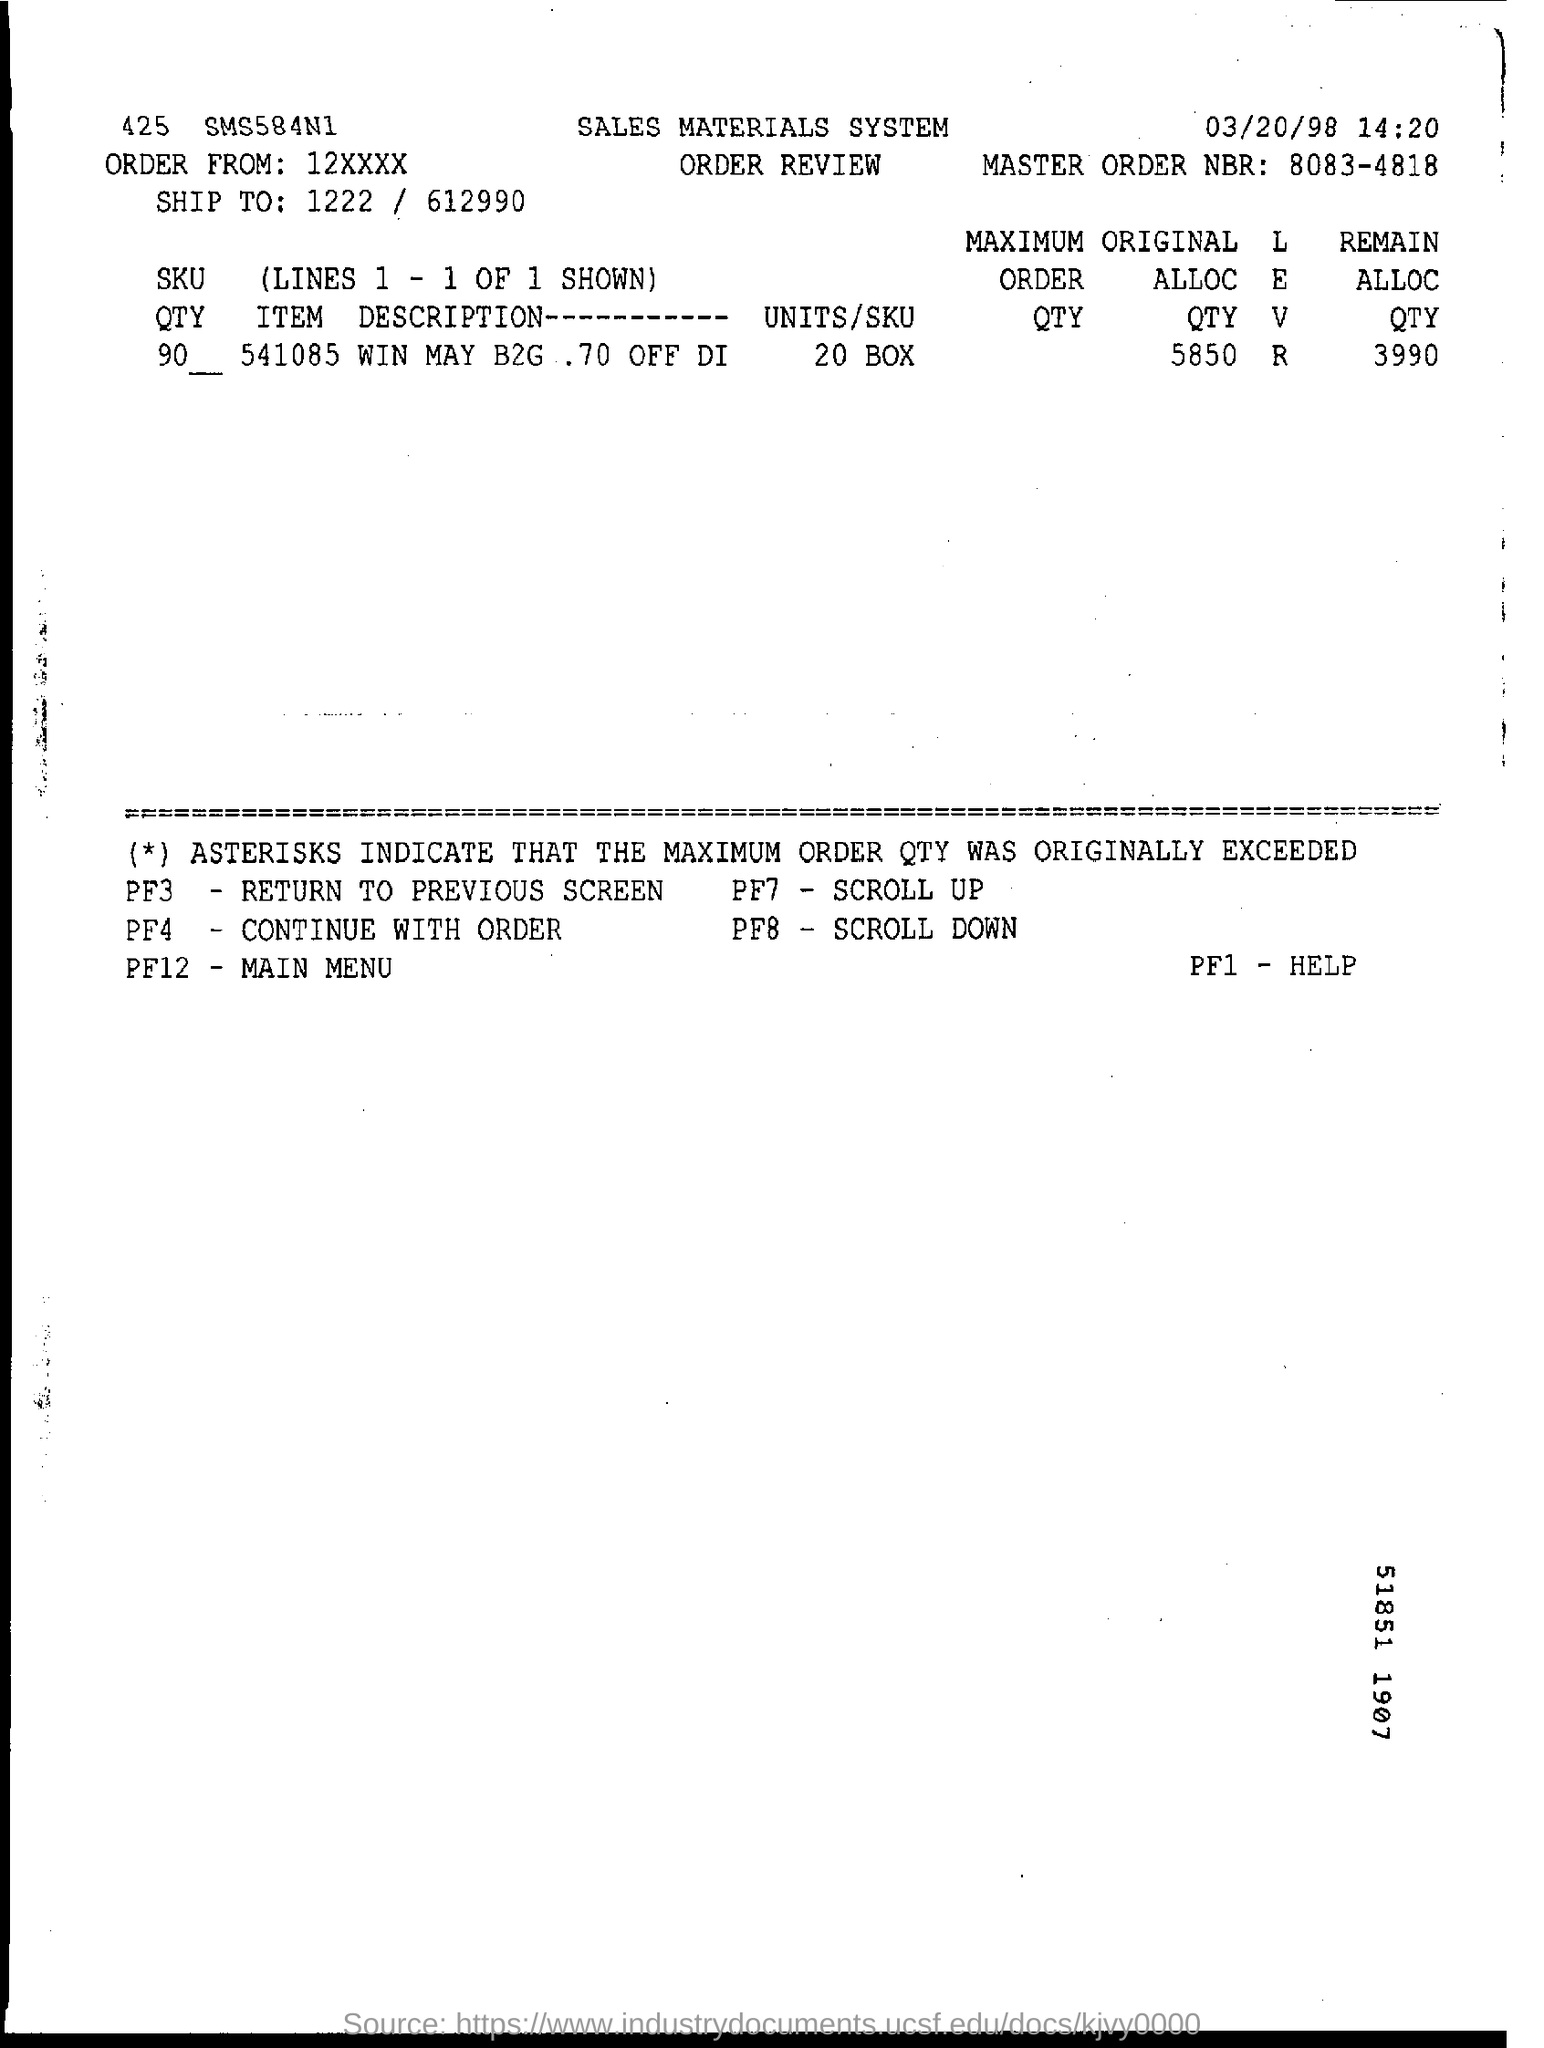List a handful of essential elements in this visual. The master order number is 8083-4818. The command "What is PF3 for? return to previous screen.." is a directive to the computer to display information about the PF3 (Power Factor) and then return to the previous screen. The item description is 541085 win may b2g, and there is a 70% discount on Di... 